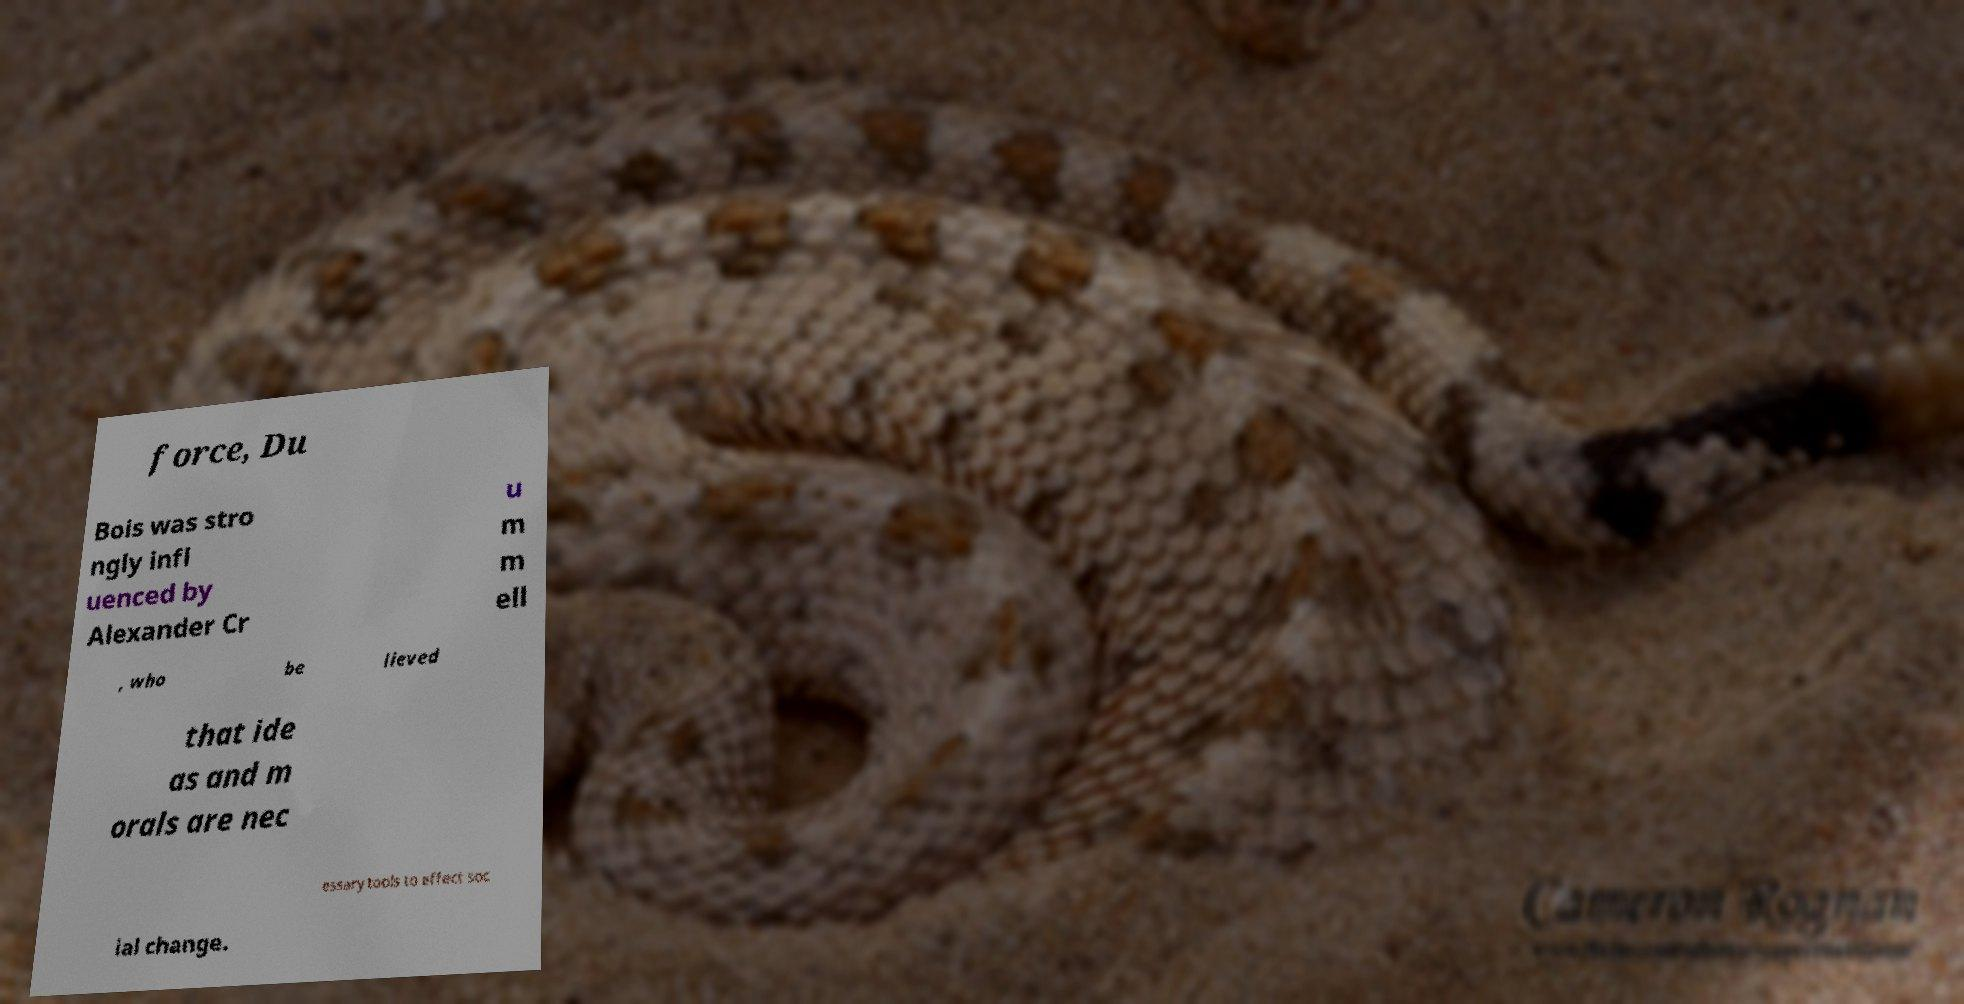I need the written content from this picture converted into text. Can you do that? force, Du Bois was stro ngly infl uenced by Alexander Cr u m m ell , who be lieved that ide as and m orals are nec essary tools to effect soc ial change. 